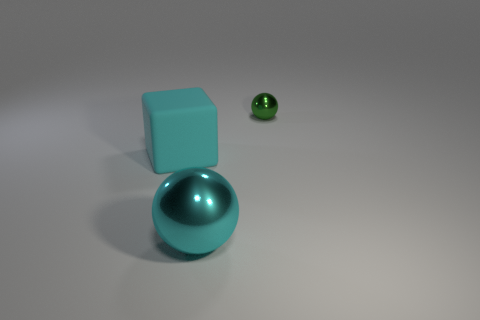Is there any other thing that has the same material as the big block?
Offer a very short reply. No. How many other objects are the same size as the green shiny ball?
Give a very brief answer. 0. Does the small metallic object have the same color as the rubber object?
Provide a succinct answer. No. There is a thing that is to the left of the shiny ball in front of the small green metallic ball; how many rubber blocks are behind it?
Your answer should be compact. 0. Is there any other thing of the same color as the tiny metallic object?
Offer a very short reply. No. Is the size of the shiny sphere in front of the block the same as the big cube?
Your answer should be compact. Yes. There is a metal object that is on the right side of the cyan metal object; what number of large matte objects are in front of it?
Make the answer very short. 1. There is a cyan object that is behind the large thing right of the big block; is there a small shiny object right of it?
Your response must be concise. Yes. What material is the tiny object that is the same shape as the big cyan shiny object?
Provide a succinct answer. Metal. Does the small green object have the same material as the sphere left of the small green object?
Keep it short and to the point. Yes. 